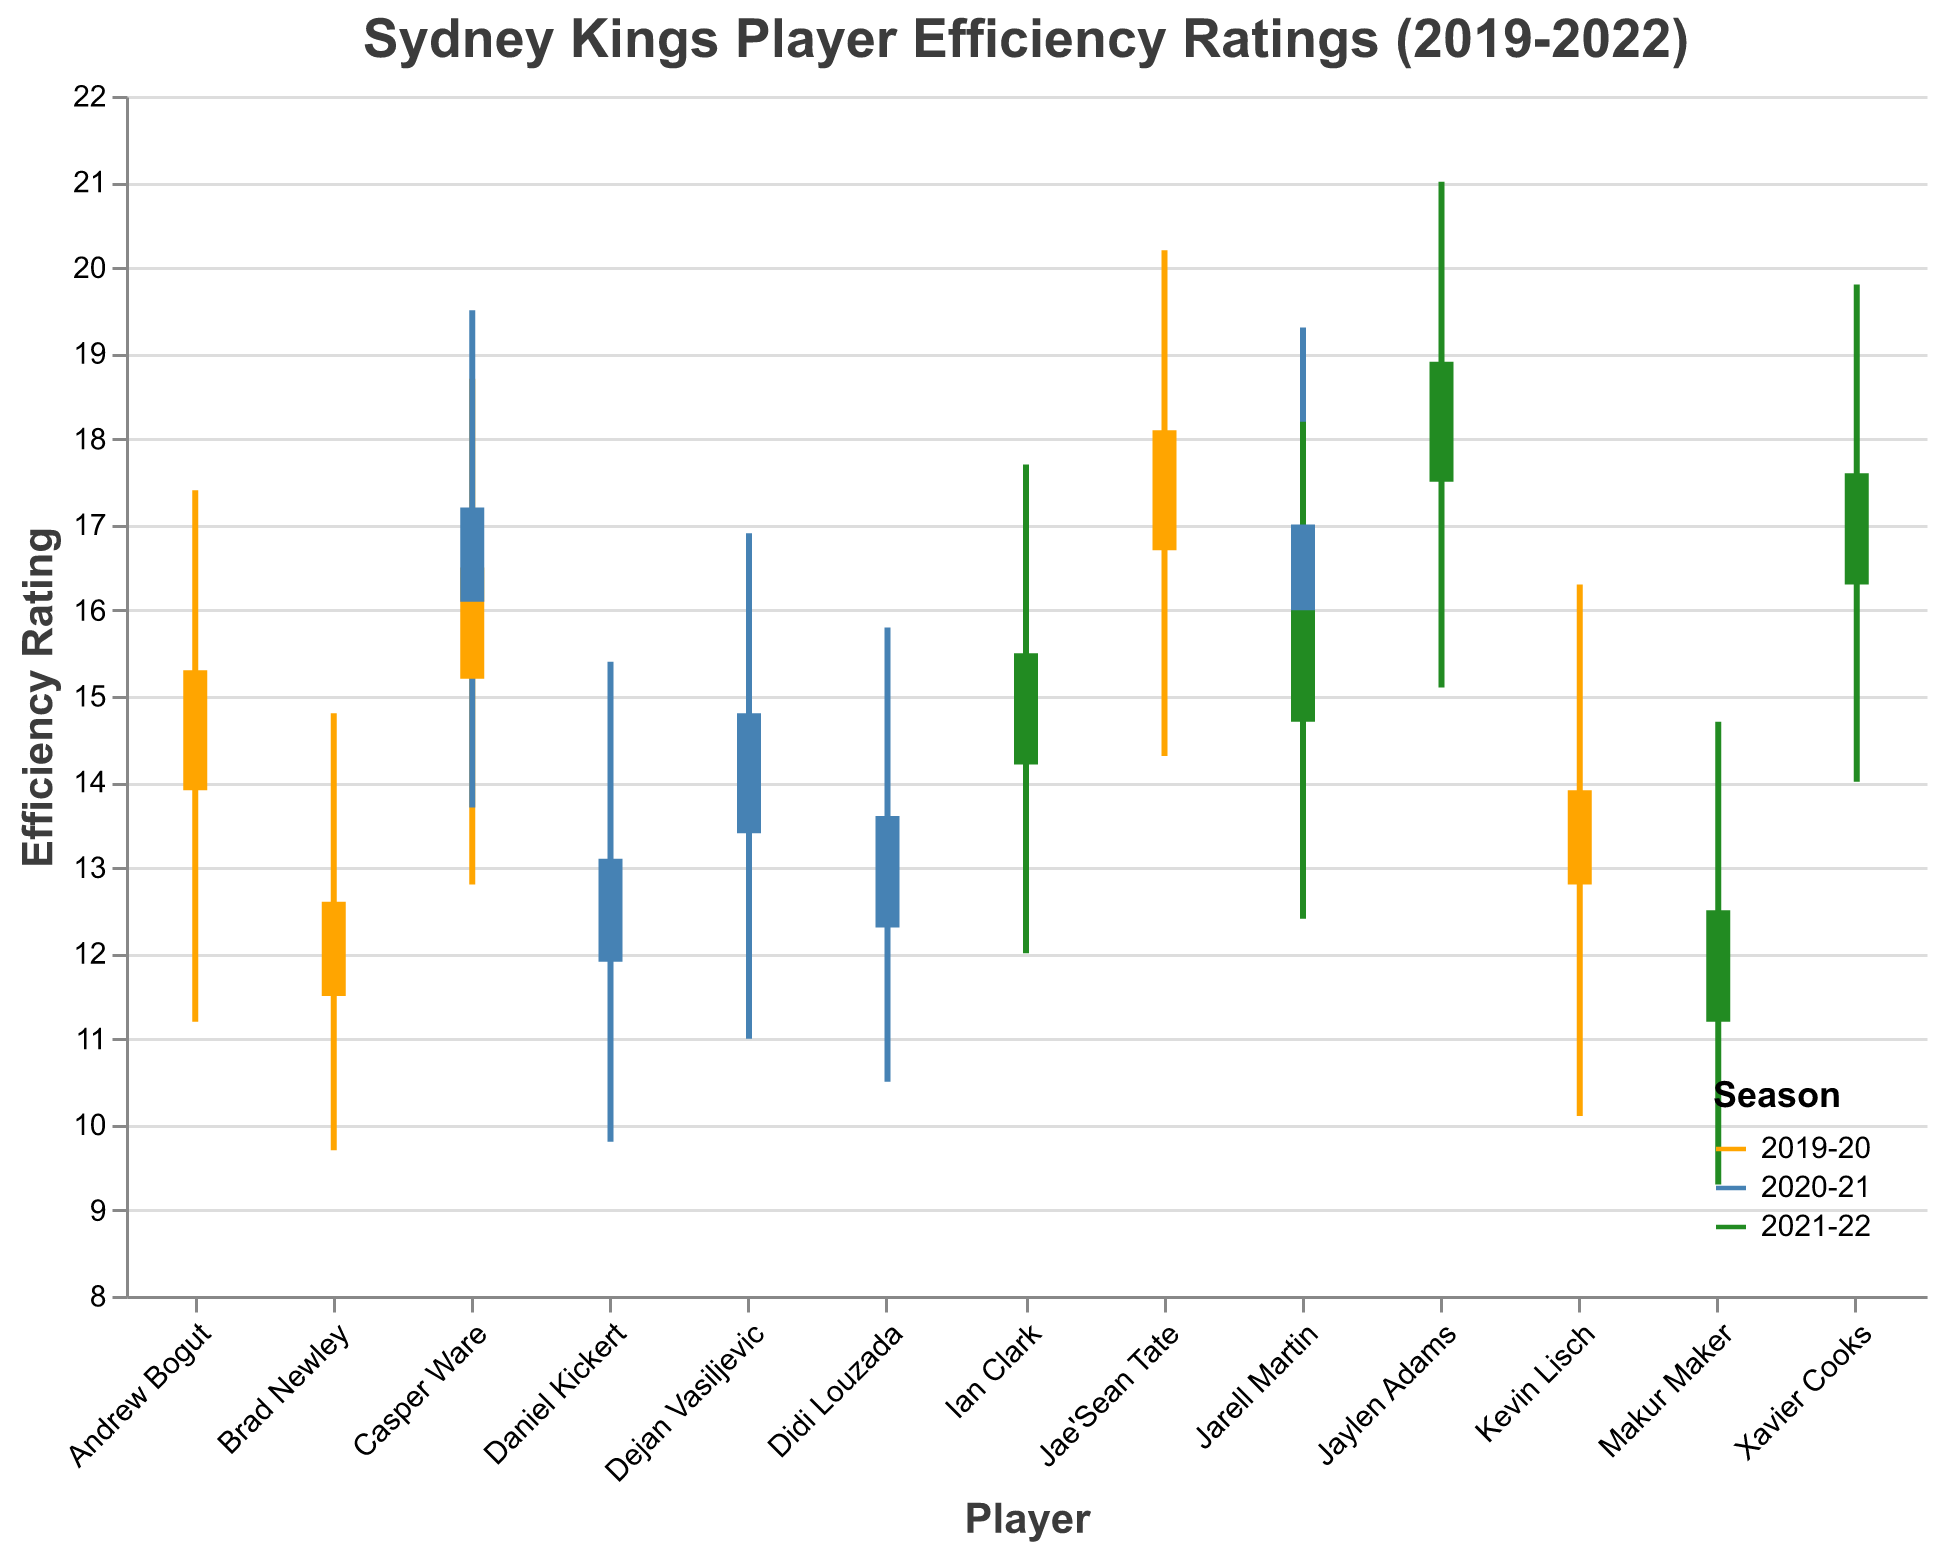What is the title of the figure? The title is located at the top of the figure and summarizes what the figure represents. It states "Sydney Kings Player Efficiency Ratings (2019-2022)", indicating that the chart displays efficiency ratings for Sydney Kings players across three seasons.
Answer: Sydney Kings Player Efficiency Ratings (2019-2022) Which season had the highest efficiency rating among all players? The highest efficiency rating can be identified by looking at the tallest "High" point among all players. Jaylen Adams in the 2021-22 season has the highest point at 21.0.
Answer: 2021-22 Compare the performance of Casper Ware across the seasons 2019-20 and 2020-21. What do you observe? Casper Ware has data points in both the 2019-20 and 2020-21 seasons. His efficiency ratings increased from 15.2 (Open) to 16.5 (Close) in 2019-20 and from 16.1 (Open) to 17.2 (Close) in 2020-21, indicating an overall improvement.
Answer: His efficiency improved from the 2019-20 to the 2020-21 season What was the range of Jae'Sean Tate's efficiency rating in the 2019-20 season? The range can be calculated by subtracting the "Low" value from the "High" value for Jae'Sean Tate in the 2019-20 season. His values are 20.2 (High) and 14.3 (Low), so the range is 20.2 - 14.3 = 5.9.
Answer: 5.9 Which player had the lowest starting efficiency rating in the 2021-22 season? To find the lowest starting efficiency rating (Open) in the 2021-22 season, we look at the figure for the lowest "Open" value among 2021-22 players, which is Makur Maker with 11.2.
Answer: Makur Maker What is the difference between the highest and lowest efficiency ratings for Kevin Lisch in the 2019-20 season? For Kevin Lisch in the 2019-20 season, the High is 16.3 and the Low is 10.1. The difference is calculated by subtracting the Low from the High: 16.3 - 10.1 = 6.2.
Answer: 6.2 Who had a better closing efficiency rating in the 2020-21 season: Casper Ware or Jarell Martin? The closing efficiency ratings (Close) for Casper Ware and Jarell Martin in the 2020-21 season are 17.2 and 17.0 respectively. Casper Ware’s closing efficiency rating is higher.
Answer: Casper Ware Which player saw the greatest improvement in efficiency rating from open to close in the 2021-22 season? To determine the greatest improvement, we subtract the "Open" rating from the "Close" rating for each 2021-22 player. Jaylen Adams improved from 17.5 to 18.9, an improvement of 1.4, which is the highest.
Answer: Jaylen Adams How does the median open efficiency rating of 2019-20 compare to that of the 2020-21 season? Identify the "Open" efficiency ratings for each player in both seasons, then find the median of those ratings. For 2019-20, the median of 15.2, 12.8, 11.5, 16.7, 13.9 is 13.9. For 2020-21, the median of 16.1, 13.4, 12.3, 15.8, 11.9 is 13.4.
Answer: The median open efficiency rating in 2019-20 is higher than in 2020-21 